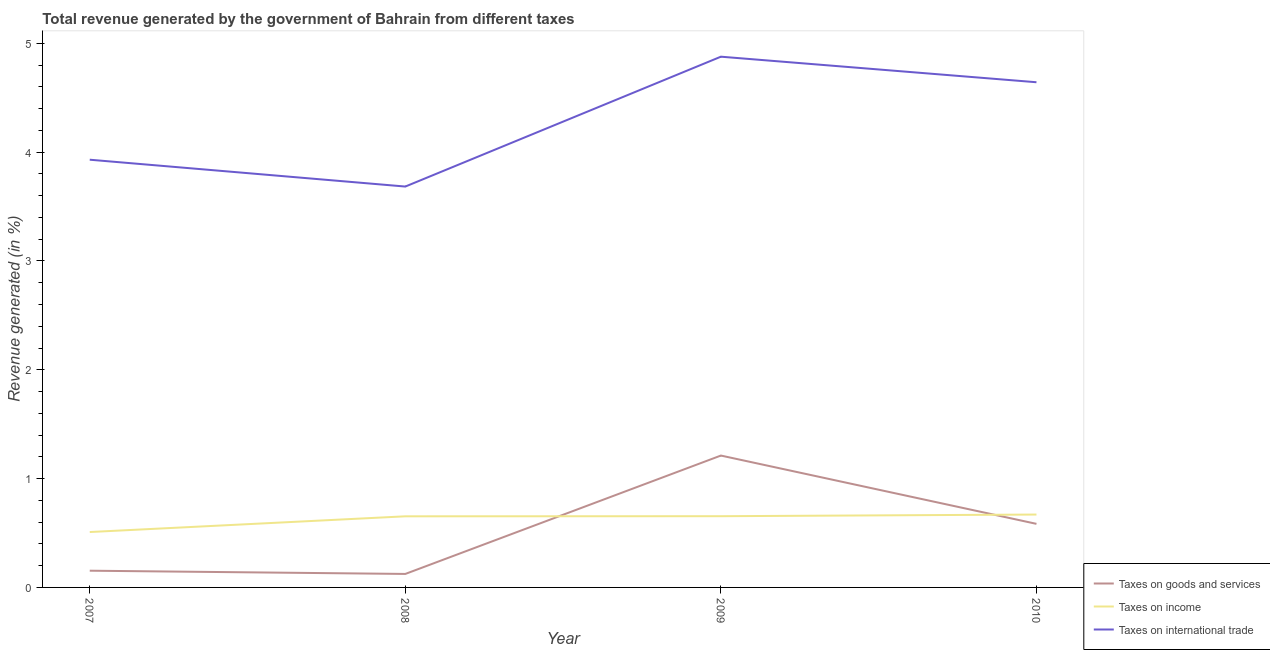Does the line corresponding to percentage of revenue generated by taxes on goods and services intersect with the line corresponding to percentage of revenue generated by tax on international trade?
Your answer should be very brief. No. What is the percentage of revenue generated by taxes on income in 2009?
Keep it short and to the point. 0.65. Across all years, what is the maximum percentage of revenue generated by taxes on goods and services?
Offer a terse response. 1.21. Across all years, what is the minimum percentage of revenue generated by taxes on income?
Provide a short and direct response. 0.51. In which year was the percentage of revenue generated by tax on international trade maximum?
Provide a short and direct response. 2009. In which year was the percentage of revenue generated by taxes on goods and services minimum?
Offer a terse response. 2008. What is the total percentage of revenue generated by tax on international trade in the graph?
Your response must be concise. 17.14. What is the difference between the percentage of revenue generated by taxes on goods and services in 2008 and that in 2010?
Keep it short and to the point. -0.46. What is the difference between the percentage of revenue generated by taxes on goods and services in 2008 and the percentage of revenue generated by tax on international trade in 2009?
Your response must be concise. -4.75. What is the average percentage of revenue generated by tax on international trade per year?
Give a very brief answer. 4.28. In the year 2008, what is the difference between the percentage of revenue generated by tax on international trade and percentage of revenue generated by taxes on income?
Ensure brevity in your answer.  3.03. In how many years, is the percentage of revenue generated by tax on international trade greater than 0.4 %?
Make the answer very short. 4. What is the ratio of the percentage of revenue generated by taxes on income in 2008 to that in 2010?
Offer a terse response. 0.98. Is the difference between the percentage of revenue generated by taxes on goods and services in 2008 and 2010 greater than the difference between the percentage of revenue generated by tax on international trade in 2008 and 2010?
Give a very brief answer. Yes. What is the difference between the highest and the second highest percentage of revenue generated by tax on international trade?
Keep it short and to the point. 0.23. What is the difference between the highest and the lowest percentage of revenue generated by taxes on goods and services?
Give a very brief answer. 1.09. In how many years, is the percentage of revenue generated by tax on international trade greater than the average percentage of revenue generated by tax on international trade taken over all years?
Give a very brief answer. 2. Is it the case that in every year, the sum of the percentage of revenue generated by taxes on goods and services and percentage of revenue generated by taxes on income is greater than the percentage of revenue generated by tax on international trade?
Offer a very short reply. No. Is the percentage of revenue generated by taxes on income strictly greater than the percentage of revenue generated by tax on international trade over the years?
Offer a terse response. No. How many years are there in the graph?
Ensure brevity in your answer.  4. Does the graph contain grids?
Offer a very short reply. No. Where does the legend appear in the graph?
Give a very brief answer. Bottom right. How many legend labels are there?
Provide a succinct answer. 3. How are the legend labels stacked?
Your answer should be compact. Vertical. What is the title of the graph?
Keep it short and to the point. Total revenue generated by the government of Bahrain from different taxes. What is the label or title of the Y-axis?
Ensure brevity in your answer.  Revenue generated (in %). What is the Revenue generated (in %) in Taxes on goods and services in 2007?
Keep it short and to the point. 0.15. What is the Revenue generated (in %) of Taxes on income in 2007?
Your response must be concise. 0.51. What is the Revenue generated (in %) in Taxes on international trade in 2007?
Your response must be concise. 3.93. What is the Revenue generated (in %) in Taxes on goods and services in 2008?
Your answer should be compact. 0.12. What is the Revenue generated (in %) in Taxes on income in 2008?
Offer a very short reply. 0.65. What is the Revenue generated (in %) in Taxes on international trade in 2008?
Give a very brief answer. 3.68. What is the Revenue generated (in %) in Taxes on goods and services in 2009?
Give a very brief answer. 1.21. What is the Revenue generated (in %) in Taxes on income in 2009?
Provide a succinct answer. 0.65. What is the Revenue generated (in %) of Taxes on international trade in 2009?
Keep it short and to the point. 4.88. What is the Revenue generated (in %) in Taxes on goods and services in 2010?
Provide a short and direct response. 0.58. What is the Revenue generated (in %) in Taxes on income in 2010?
Provide a succinct answer. 0.67. What is the Revenue generated (in %) in Taxes on international trade in 2010?
Make the answer very short. 4.64. Across all years, what is the maximum Revenue generated (in %) of Taxes on goods and services?
Offer a terse response. 1.21. Across all years, what is the maximum Revenue generated (in %) in Taxes on income?
Offer a very short reply. 0.67. Across all years, what is the maximum Revenue generated (in %) of Taxes on international trade?
Your answer should be very brief. 4.88. Across all years, what is the minimum Revenue generated (in %) of Taxes on goods and services?
Offer a very short reply. 0.12. Across all years, what is the minimum Revenue generated (in %) of Taxes on income?
Your answer should be compact. 0.51. Across all years, what is the minimum Revenue generated (in %) of Taxes on international trade?
Ensure brevity in your answer.  3.68. What is the total Revenue generated (in %) of Taxes on goods and services in the graph?
Provide a succinct answer. 2.07. What is the total Revenue generated (in %) in Taxes on income in the graph?
Offer a terse response. 2.49. What is the total Revenue generated (in %) of Taxes on international trade in the graph?
Provide a short and direct response. 17.14. What is the difference between the Revenue generated (in %) of Taxes on goods and services in 2007 and that in 2008?
Offer a terse response. 0.03. What is the difference between the Revenue generated (in %) of Taxes on income in 2007 and that in 2008?
Offer a terse response. -0.14. What is the difference between the Revenue generated (in %) of Taxes on international trade in 2007 and that in 2008?
Your response must be concise. 0.25. What is the difference between the Revenue generated (in %) of Taxes on goods and services in 2007 and that in 2009?
Your answer should be compact. -1.06. What is the difference between the Revenue generated (in %) in Taxes on income in 2007 and that in 2009?
Your response must be concise. -0.15. What is the difference between the Revenue generated (in %) in Taxes on international trade in 2007 and that in 2009?
Your response must be concise. -0.95. What is the difference between the Revenue generated (in %) of Taxes on goods and services in 2007 and that in 2010?
Your response must be concise. -0.43. What is the difference between the Revenue generated (in %) of Taxes on income in 2007 and that in 2010?
Your answer should be very brief. -0.16. What is the difference between the Revenue generated (in %) in Taxes on international trade in 2007 and that in 2010?
Keep it short and to the point. -0.71. What is the difference between the Revenue generated (in %) of Taxes on goods and services in 2008 and that in 2009?
Give a very brief answer. -1.09. What is the difference between the Revenue generated (in %) in Taxes on income in 2008 and that in 2009?
Your answer should be compact. -0. What is the difference between the Revenue generated (in %) of Taxes on international trade in 2008 and that in 2009?
Give a very brief answer. -1.19. What is the difference between the Revenue generated (in %) in Taxes on goods and services in 2008 and that in 2010?
Give a very brief answer. -0.46. What is the difference between the Revenue generated (in %) in Taxes on income in 2008 and that in 2010?
Your answer should be very brief. -0.02. What is the difference between the Revenue generated (in %) in Taxes on international trade in 2008 and that in 2010?
Ensure brevity in your answer.  -0.96. What is the difference between the Revenue generated (in %) of Taxes on goods and services in 2009 and that in 2010?
Offer a very short reply. 0.63. What is the difference between the Revenue generated (in %) of Taxes on income in 2009 and that in 2010?
Provide a succinct answer. -0.02. What is the difference between the Revenue generated (in %) of Taxes on international trade in 2009 and that in 2010?
Your answer should be compact. 0.23. What is the difference between the Revenue generated (in %) of Taxes on goods and services in 2007 and the Revenue generated (in %) of Taxes on income in 2008?
Your answer should be very brief. -0.5. What is the difference between the Revenue generated (in %) in Taxes on goods and services in 2007 and the Revenue generated (in %) in Taxes on international trade in 2008?
Give a very brief answer. -3.53. What is the difference between the Revenue generated (in %) of Taxes on income in 2007 and the Revenue generated (in %) of Taxes on international trade in 2008?
Your answer should be compact. -3.17. What is the difference between the Revenue generated (in %) in Taxes on goods and services in 2007 and the Revenue generated (in %) in Taxes on income in 2009?
Your answer should be compact. -0.5. What is the difference between the Revenue generated (in %) of Taxes on goods and services in 2007 and the Revenue generated (in %) of Taxes on international trade in 2009?
Make the answer very short. -4.72. What is the difference between the Revenue generated (in %) of Taxes on income in 2007 and the Revenue generated (in %) of Taxes on international trade in 2009?
Your answer should be compact. -4.37. What is the difference between the Revenue generated (in %) in Taxes on goods and services in 2007 and the Revenue generated (in %) in Taxes on income in 2010?
Provide a short and direct response. -0.52. What is the difference between the Revenue generated (in %) in Taxes on goods and services in 2007 and the Revenue generated (in %) in Taxes on international trade in 2010?
Ensure brevity in your answer.  -4.49. What is the difference between the Revenue generated (in %) in Taxes on income in 2007 and the Revenue generated (in %) in Taxes on international trade in 2010?
Provide a succinct answer. -4.13. What is the difference between the Revenue generated (in %) of Taxes on goods and services in 2008 and the Revenue generated (in %) of Taxes on income in 2009?
Your response must be concise. -0.53. What is the difference between the Revenue generated (in %) of Taxes on goods and services in 2008 and the Revenue generated (in %) of Taxes on international trade in 2009?
Keep it short and to the point. -4.75. What is the difference between the Revenue generated (in %) in Taxes on income in 2008 and the Revenue generated (in %) in Taxes on international trade in 2009?
Offer a terse response. -4.22. What is the difference between the Revenue generated (in %) of Taxes on goods and services in 2008 and the Revenue generated (in %) of Taxes on income in 2010?
Provide a succinct answer. -0.55. What is the difference between the Revenue generated (in %) in Taxes on goods and services in 2008 and the Revenue generated (in %) in Taxes on international trade in 2010?
Your response must be concise. -4.52. What is the difference between the Revenue generated (in %) of Taxes on income in 2008 and the Revenue generated (in %) of Taxes on international trade in 2010?
Your answer should be compact. -3.99. What is the difference between the Revenue generated (in %) in Taxes on goods and services in 2009 and the Revenue generated (in %) in Taxes on income in 2010?
Ensure brevity in your answer.  0.54. What is the difference between the Revenue generated (in %) in Taxes on goods and services in 2009 and the Revenue generated (in %) in Taxes on international trade in 2010?
Your response must be concise. -3.43. What is the difference between the Revenue generated (in %) in Taxes on income in 2009 and the Revenue generated (in %) in Taxes on international trade in 2010?
Your answer should be very brief. -3.99. What is the average Revenue generated (in %) of Taxes on goods and services per year?
Ensure brevity in your answer.  0.52. What is the average Revenue generated (in %) of Taxes on income per year?
Your response must be concise. 0.62. What is the average Revenue generated (in %) of Taxes on international trade per year?
Your answer should be compact. 4.28. In the year 2007, what is the difference between the Revenue generated (in %) of Taxes on goods and services and Revenue generated (in %) of Taxes on income?
Make the answer very short. -0.36. In the year 2007, what is the difference between the Revenue generated (in %) of Taxes on goods and services and Revenue generated (in %) of Taxes on international trade?
Ensure brevity in your answer.  -3.78. In the year 2007, what is the difference between the Revenue generated (in %) of Taxes on income and Revenue generated (in %) of Taxes on international trade?
Your answer should be compact. -3.42. In the year 2008, what is the difference between the Revenue generated (in %) in Taxes on goods and services and Revenue generated (in %) in Taxes on income?
Your answer should be very brief. -0.53. In the year 2008, what is the difference between the Revenue generated (in %) of Taxes on goods and services and Revenue generated (in %) of Taxes on international trade?
Your answer should be very brief. -3.56. In the year 2008, what is the difference between the Revenue generated (in %) in Taxes on income and Revenue generated (in %) in Taxes on international trade?
Your answer should be compact. -3.03. In the year 2009, what is the difference between the Revenue generated (in %) in Taxes on goods and services and Revenue generated (in %) in Taxes on income?
Keep it short and to the point. 0.56. In the year 2009, what is the difference between the Revenue generated (in %) of Taxes on goods and services and Revenue generated (in %) of Taxes on international trade?
Keep it short and to the point. -3.67. In the year 2009, what is the difference between the Revenue generated (in %) in Taxes on income and Revenue generated (in %) in Taxes on international trade?
Your response must be concise. -4.22. In the year 2010, what is the difference between the Revenue generated (in %) of Taxes on goods and services and Revenue generated (in %) of Taxes on income?
Keep it short and to the point. -0.09. In the year 2010, what is the difference between the Revenue generated (in %) of Taxes on goods and services and Revenue generated (in %) of Taxes on international trade?
Keep it short and to the point. -4.06. In the year 2010, what is the difference between the Revenue generated (in %) in Taxes on income and Revenue generated (in %) in Taxes on international trade?
Provide a short and direct response. -3.97. What is the ratio of the Revenue generated (in %) in Taxes on goods and services in 2007 to that in 2008?
Offer a terse response. 1.24. What is the ratio of the Revenue generated (in %) in Taxes on income in 2007 to that in 2008?
Your answer should be compact. 0.78. What is the ratio of the Revenue generated (in %) of Taxes on international trade in 2007 to that in 2008?
Your answer should be compact. 1.07. What is the ratio of the Revenue generated (in %) in Taxes on goods and services in 2007 to that in 2009?
Give a very brief answer. 0.13. What is the ratio of the Revenue generated (in %) in Taxes on income in 2007 to that in 2009?
Your answer should be very brief. 0.78. What is the ratio of the Revenue generated (in %) in Taxes on international trade in 2007 to that in 2009?
Your answer should be very brief. 0.81. What is the ratio of the Revenue generated (in %) in Taxes on goods and services in 2007 to that in 2010?
Your answer should be compact. 0.26. What is the ratio of the Revenue generated (in %) of Taxes on income in 2007 to that in 2010?
Make the answer very short. 0.76. What is the ratio of the Revenue generated (in %) in Taxes on international trade in 2007 to that in 2010?
Ensure brevity in your answer.  0.85. What is the ratio of the Revenue generated (in %) of Taxes on goods and services in 2008 to that in 2009?
Provide a short and direct response. 0.1. What is the ratio of the Revenue generated (in %) in Taxes on income in 2008 to that in 2009?
Provide a succinct answer. 1. What is the ratio of the Revenue generated (in %) of Taxes on international trade in 2008 to that in 2009?
Make the answer very short. 0.76. What is the ratio of the Revenue generated (in %) of Taxes on goods and services in 2008 to that in 2010?
Keep it short and to the point. 0.21. What is the ratio of the Revenue generated (in %) of Taxes on income in 2008 to that in 2010?
Provide a succinct answer. 0.98. What is the ratio of the Revenue generated (in %) in Taxes on international trade in 2008 to that in 2010?
Your response must be concise. 0.79. What is the ratio of the Revenue generated (in %) of Taxes on goods and services in 2009 to that in 2010?
Your response must be concise. 2.07. What is the ratio of the Revenue generated (in %) in Taxes on income in 2009 to that in 2010?
Keep it short and to the point. 0.98. What is the ratio of the Revenue generated (in %) in Taxes on international trade in 2009 to that in 2010?
Your response must be concise. 1.05. What is the difference between the highest and the second highest Revenue generated (in %) of Taxes on goods and services?
Give a very brief answer. 0.63. What is the difference between the highest and the second highest Revenue generated (in %) of Taxes on income?
Give a very brief answer. 0.02. What is the difference between the highest and the second highest Revenue generated (in %) of Taxes on international trade?
Your answer should be very brief. 0.23. What is the difference between the highest and the lowest Revenue generated (in %) in Taxes on goods and services?
Offer a very short reply. 1.09. What is the difference between the highest and the lowest Revenue generated (in %) in Taxes on income?
Offer a terse response. 0.16. What is the difference between the highest and the lowest Revenue generated (in %) in Taxes on international trade?
Provide a succinct answer. 1.19. 